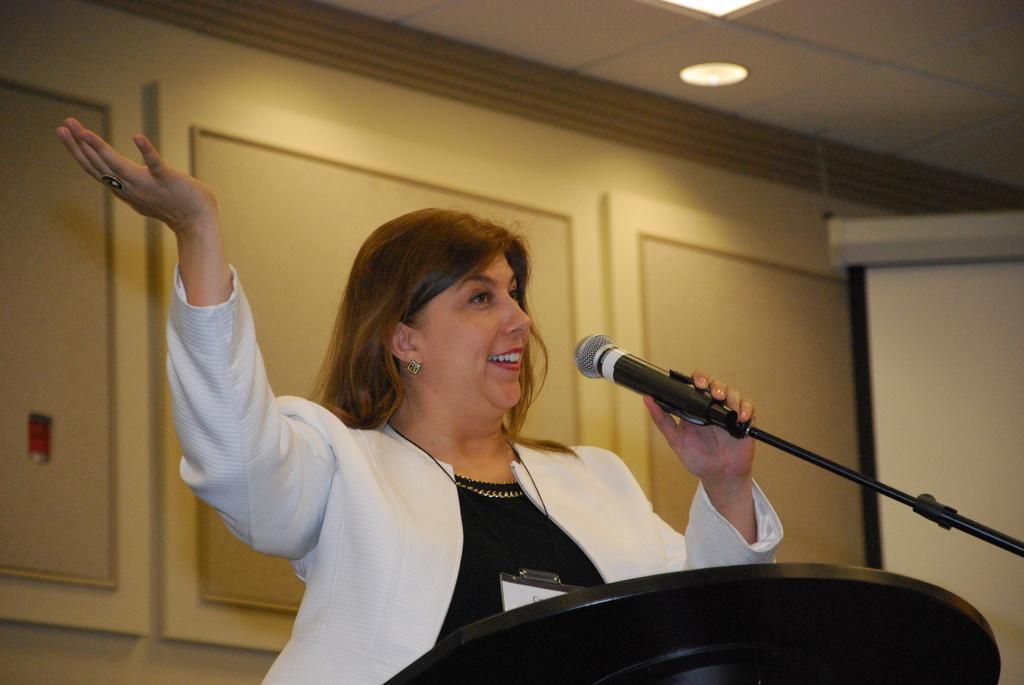Describe this image in one or two sentences. This picture shows a woman standing near the podium, holding a mic and speaking. In the background there is a wall. 